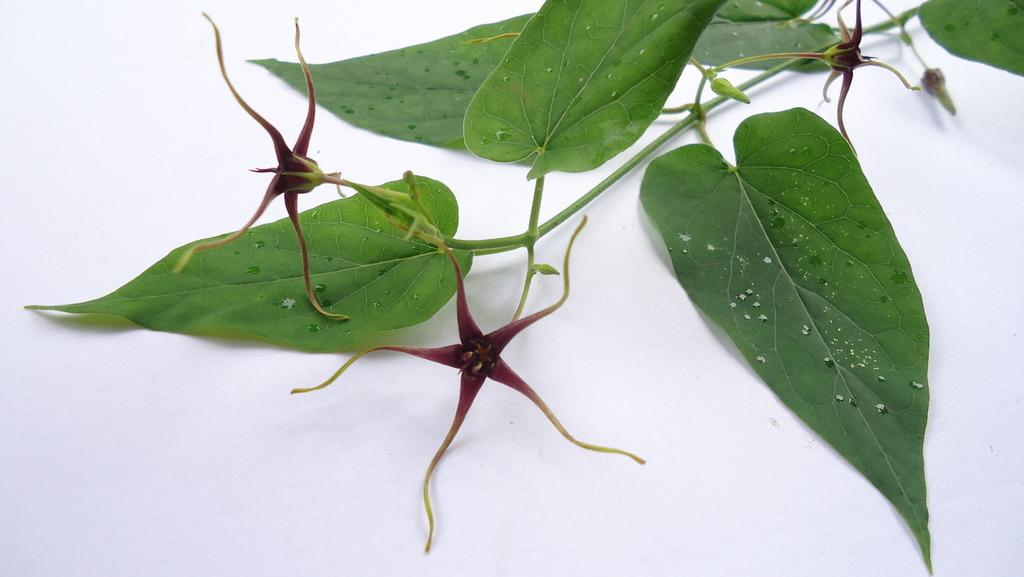What type of plant material can be seen in the image? There are leaves and a flower in the image. What is the color of the table in the image? The table in the image is white. What type of cloth is draped over the flower in the image? There is no cloth present in the image, and the flower is not draped with any material. 